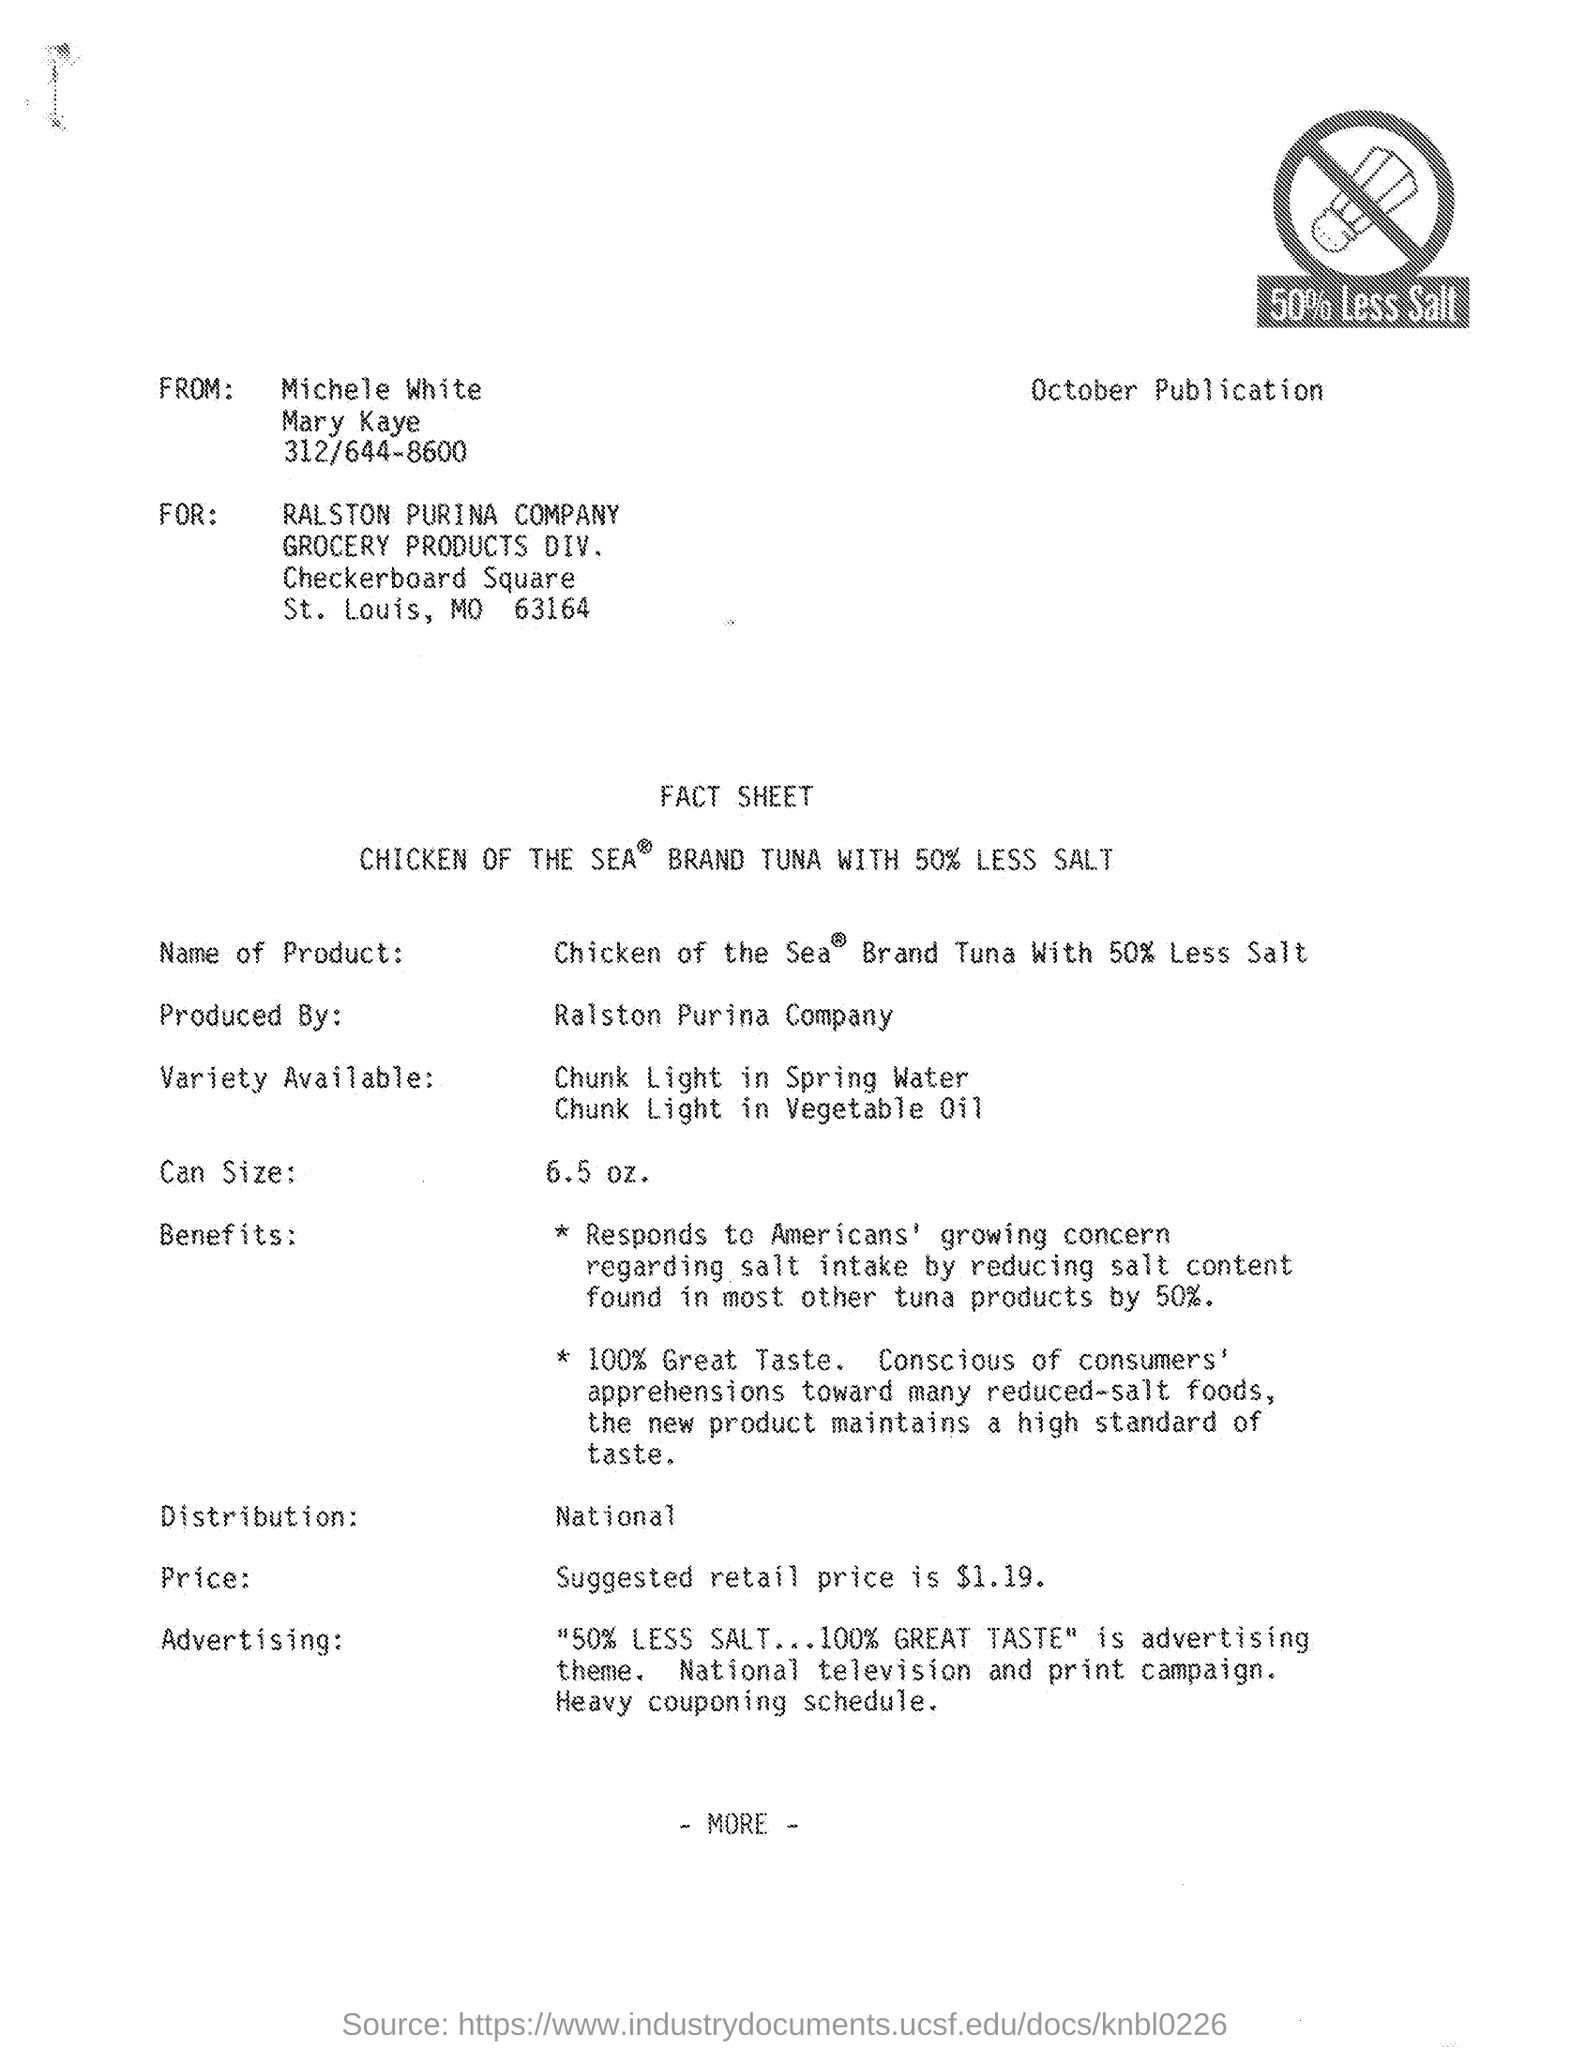What advertising strategies are mentioned for promoting this product? The product is advertised with the theme '50% LESS SALT...100% GREAT TASTE.' The campaign includes national television and print advertisements, along with a heavy couponing schedule to encourage purchases. What's the price point for the tuna can? The suggested retail price for the can of Chicken of the Sea brand tuna is $1.19, making it an affordable option for many consumers. 